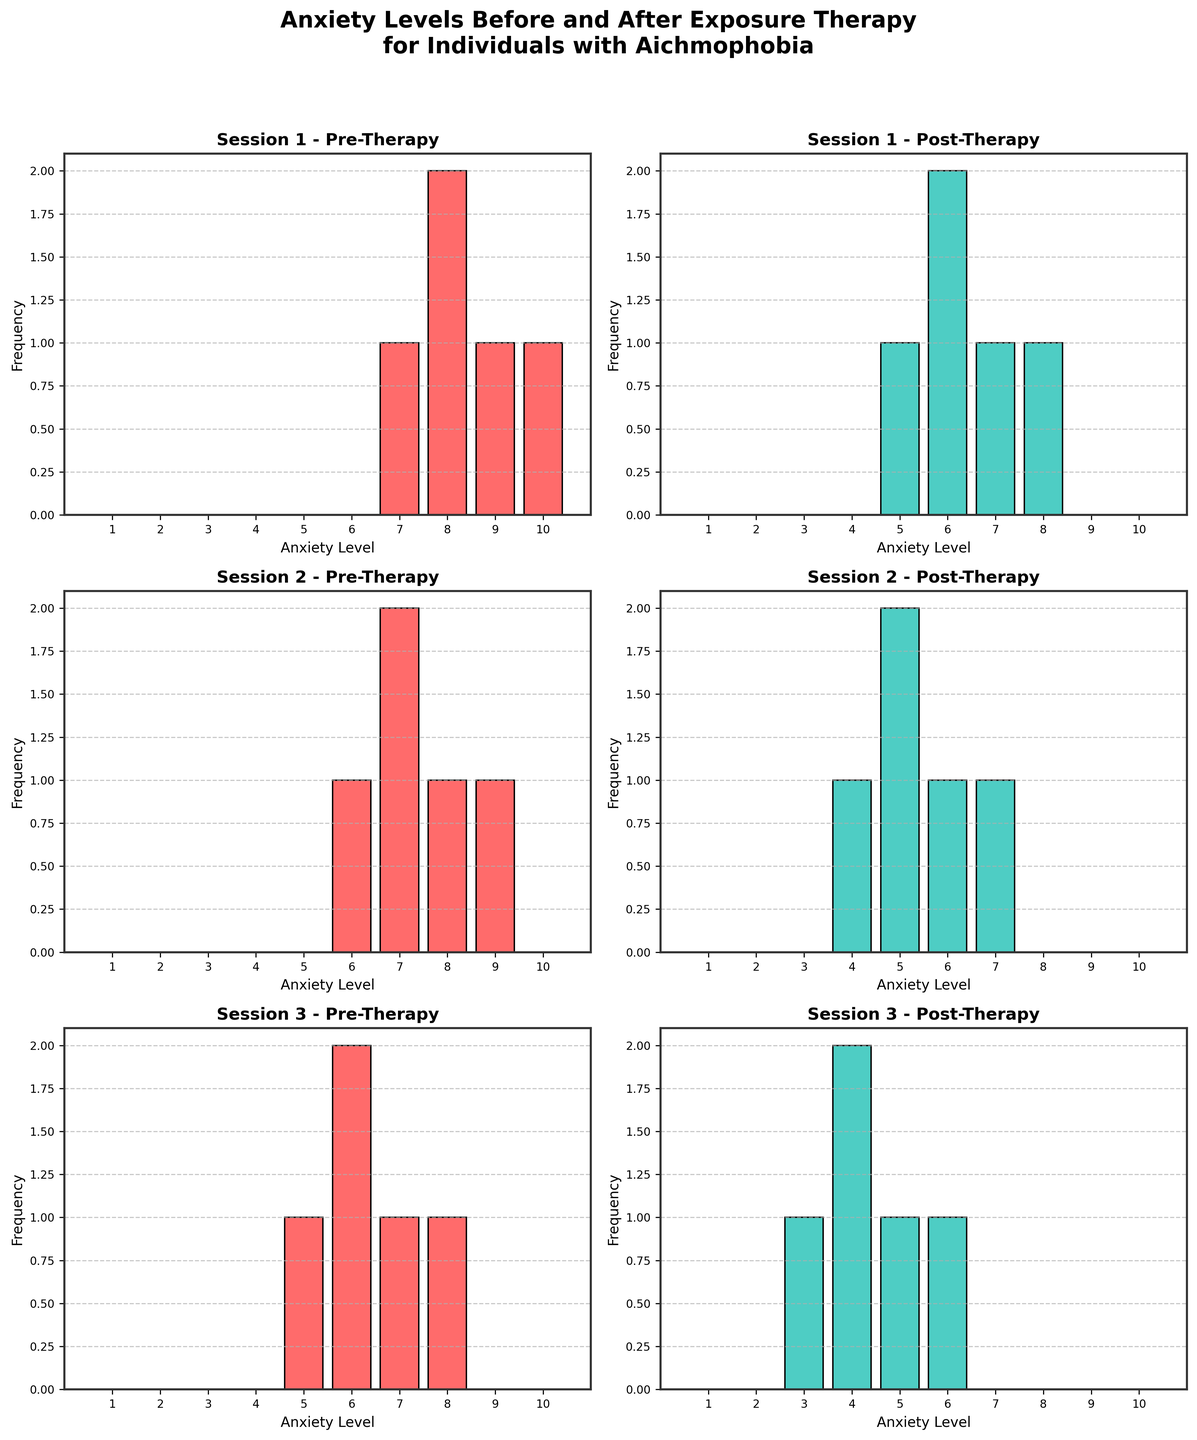What's the title of the figure? The title is usually found at the top of the figure. Before the histograms, it's written as "Anxiety Levels Before and After Exposure Therapy for Individuals with Aichmophobia".
Answer: Anxiety Levels Before and After Exposure Therapy for Individuals with Aichmophobia What stages are compared in each session? By looking at the histograms, each session has two subplots labeled with stages. These stages are labeled as "Pre-Therapy" and "Post-Therapy".
Answer: Pre-Therapy and Post-Therapy Which anxiety level frequency is most common in Session 1 Pre-Therapy? Examine the histogram bar heights for Session 1 Pre-Therapy. The tallest bar represents the most common anxiety level, which is 8.
Answer: 8 By how much does the maximum frequency of anxiety level decrease from Session 1 Pre-Therapy to Session 1 Post-Therapy? The tallest bar in Session 1 Pre-Therapy represents a frequency of 4, while in Session 1 Post-Therapy the tallest bar is at a frequency of 3. The decrease in frequency is 4 - 3 = 1.
Answer: 1 Which session has the largest decrease in the highest anxiety level after therapy? Compare the frequencies of the highest anxiety level in "Pre-Therapy" and "Post-Therapy" subplots for each session. In Session 3, the highest pre-therapy anxiety level is 8, and it decreases to 6 post-therapy. This is a decrease of 2, the largest among all sessions.
Answer: Session 3 What is the total number of anxiety level ratings in Session 2 Post-Therapy? Sum the frequencies of all anxiety levels in the Session 2 Post-Therapy histogram. The frequencies provided are 5+4+6+5+7, summing up to 27.
Answer: 27 Is the average anxiety level generally higher before or after therapy? Normally, high frequencies shift to the left post-therapy. Observing all sessions, the majority average anxiety is slightly decreased in post-therapy.
Answer: Before therapy How many anxiety levels are represented in the Post-Therapy stage across all sessions? Count the unique anxiety levels in the "Post-Therapy" histograms across all sessions. The unique levels from 3-8 are observed.
Answer: 6 Which session saw the largest reduction in average anxiety levels post-therapy? Calculate the average anxiety levels for each session pre- and post-therapy, then find the session with the largest difference. In Session 3, the average for Pre-Therapy (6.4) markedly decreases to Post-Therapy (4.4).
Answer: Session 3 Do any sessions have a higher maximum frequency post-therapy compared to pre-therapy? Compare the highest bars in each pre-therapy and post-therapy histogram. No post-therapy histogram bar exceeds its matching pre-therapy bar.
Answer: No 